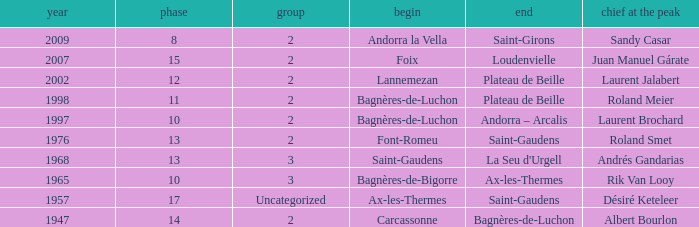Name the start of an event in Catagory 2 of the year 1947. Carcassonne. 